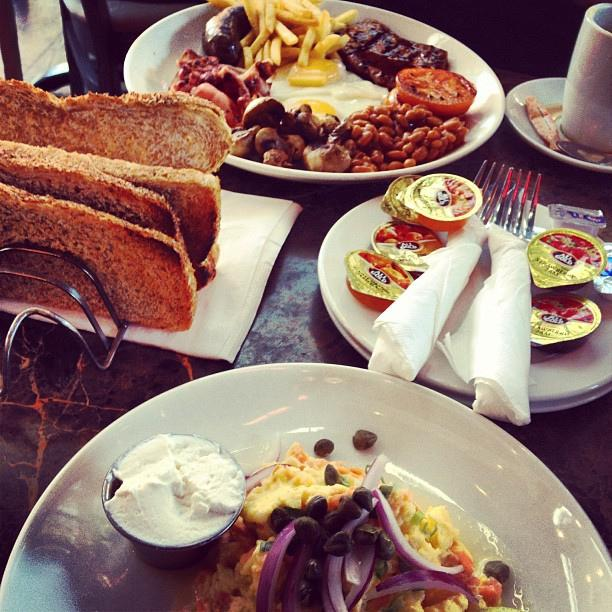What is on the plate with the two wrapped forks?

Choices:
A) butter jelly
B) mayonnaise
C) ketchup
D) mustard butter jelly 